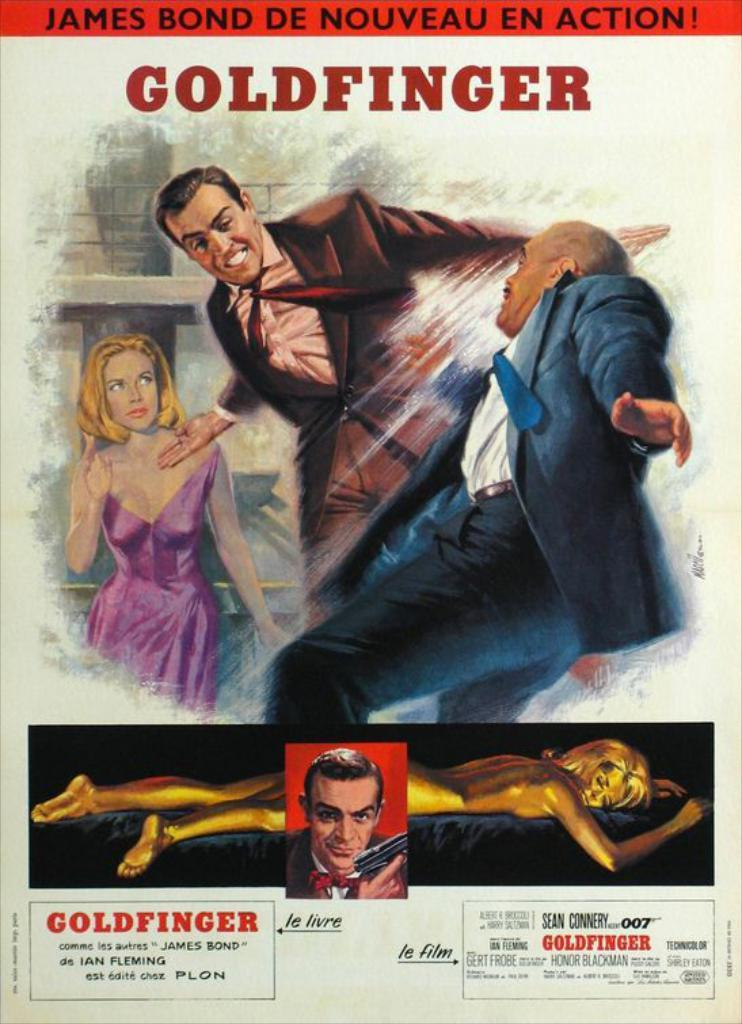Provide a one-sentence caption for the provided image. A movie poster advertising Goldfinger, James Bond de noveau en action. 